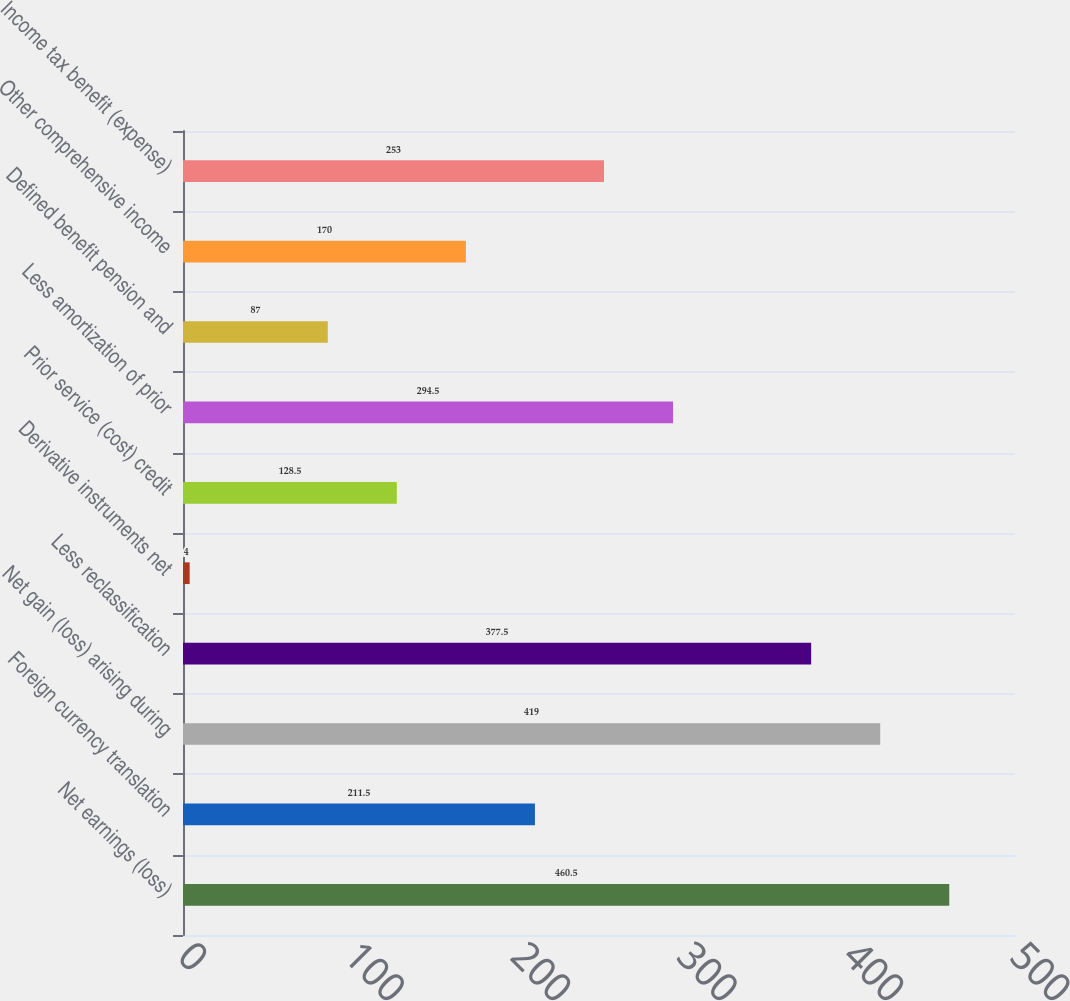<chart> <loc_0><loc_0><loc_500><loc_500><bar_chart><fcel>Net earnings (loss)<fcel>Foreign currency translation<fcel>Net gain (loss) arising during<fcel>Less reclassification<fcel>Derivative instruments net<fcel>Prior service (cost) credit<fcel>Less amortization of prior<fcel>Defined benefit pension and<fcel>Other comprehensive income<fcel>Income tax benefit (expense)<nl><fcel>460.5<fcel>211.5<fcel>419<fcel>377.5<fcel>4<fcel>128.5<fcel>294.5<fcel>87<fcel>170<fcel>253<nl></chart> 